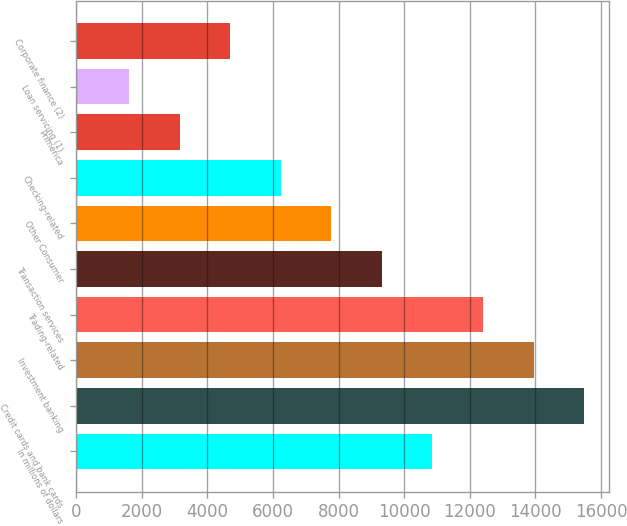Convert chart to OTSL. <chart><loc_0><loc_0><loc_500><loc_500><bar_chart><fcel>In millions of dollars<fcel>Credit cards and bank cards<fcel>Investment banking<fcel>Trading-related<fcel>Transaction services<fcel>Other Consumer<fcel>Checking-related<fcel>Primerica<fcel>Loan servicing (1)<fcel>Corporate finance (2)<nl><fcel>10863.2<fcel>15485<fcel>13944.4<fcel>12403.8<fcel>9322.6<fcel>7782<fcel>6241.4<fcel>3160.2<fcel>1619.6<fcel>4700.8<nl></chart> 